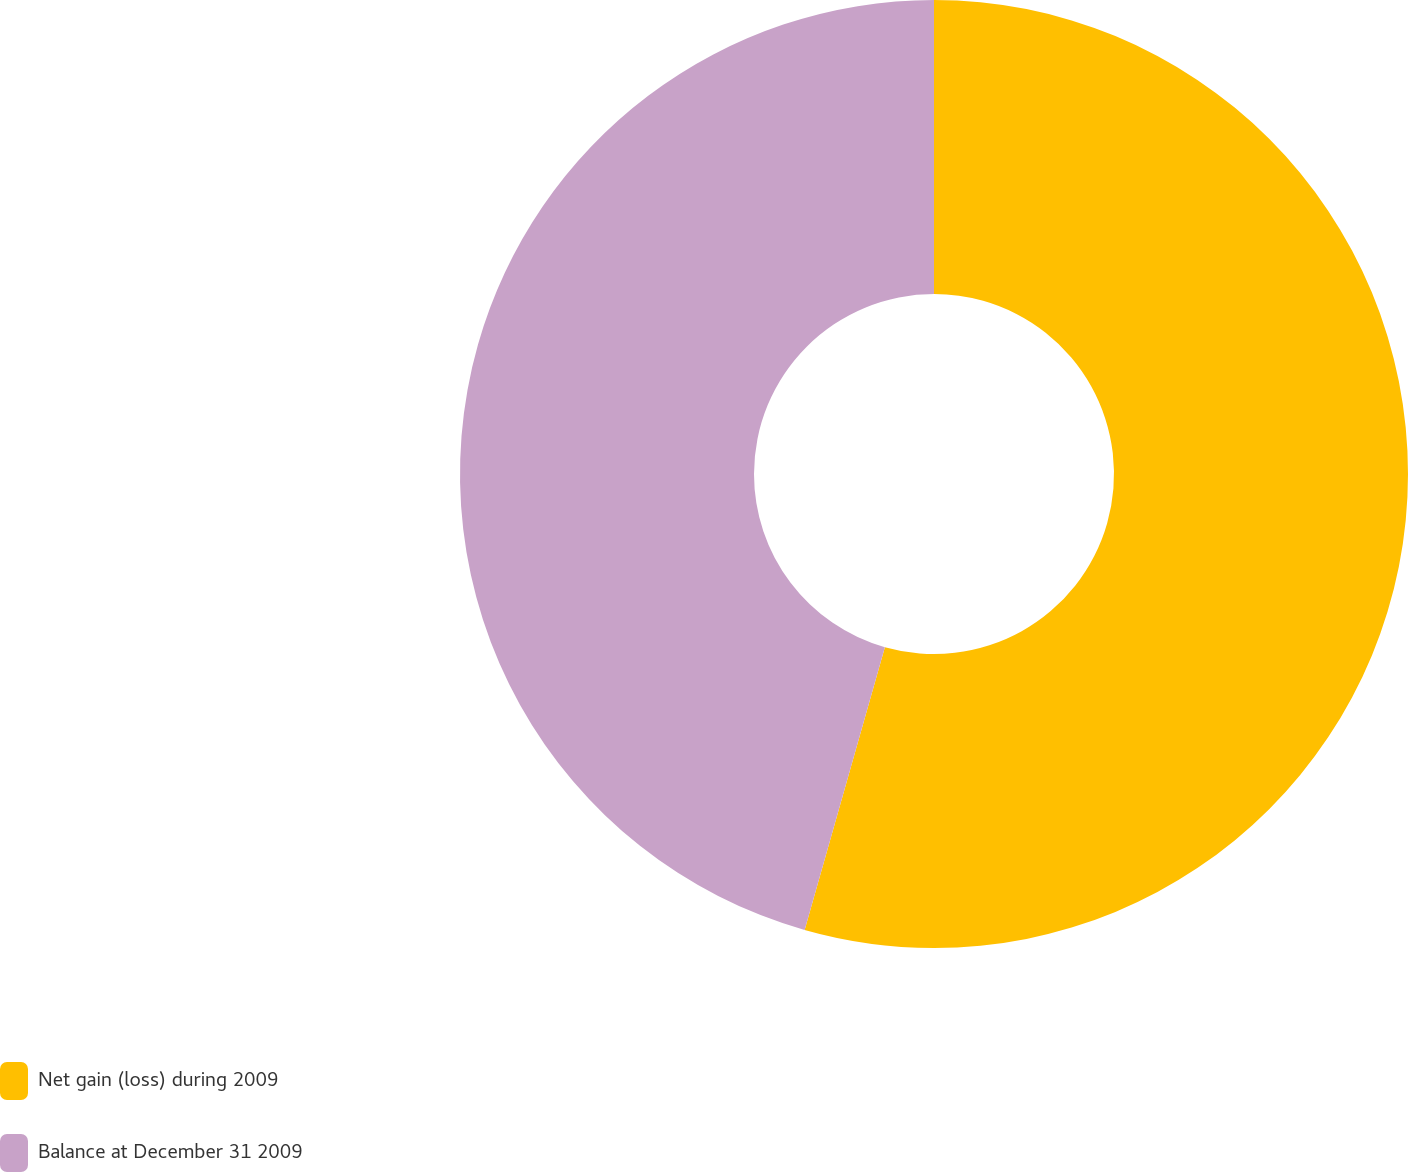Convert chart. <chart><loc_0><loc_0><loc_500><loc_500><pie_chart><fcel>Net gain (loss) during 2009<fcel>Balance at December 31 2009<nl><fcel>54.4%<fcel>45.6%<nl></chart> 